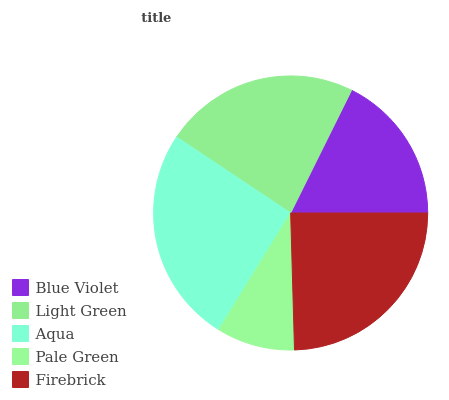Is Pale Green the minimum?
Answer yes or no. Yes. Is Aqua the maximum?
Answer yes or no. Yes. Is Light Green the minimum?
Answer yes or no. No. Is Light Green the maximum?
Answer yes or no. No. Is Light Green greater than Blue Violet?
Answer yes or no. Yes. Is Blue Violet less than Light Green?
Answer yes or no. Yes. Is Blue Violet greater than Light Green?
Answer yes or no. No. Is Light Green less than Blue Violet?
Answer yes or no. No. Is Light Green the high median?
Answer yes or no. Yes. Is Light Green the low median?
Answer yes or no. Yes. Is Firebrick the high median?
Answer yes or no. No. Is Firebrick the low median?
Answer yes or no. No. 